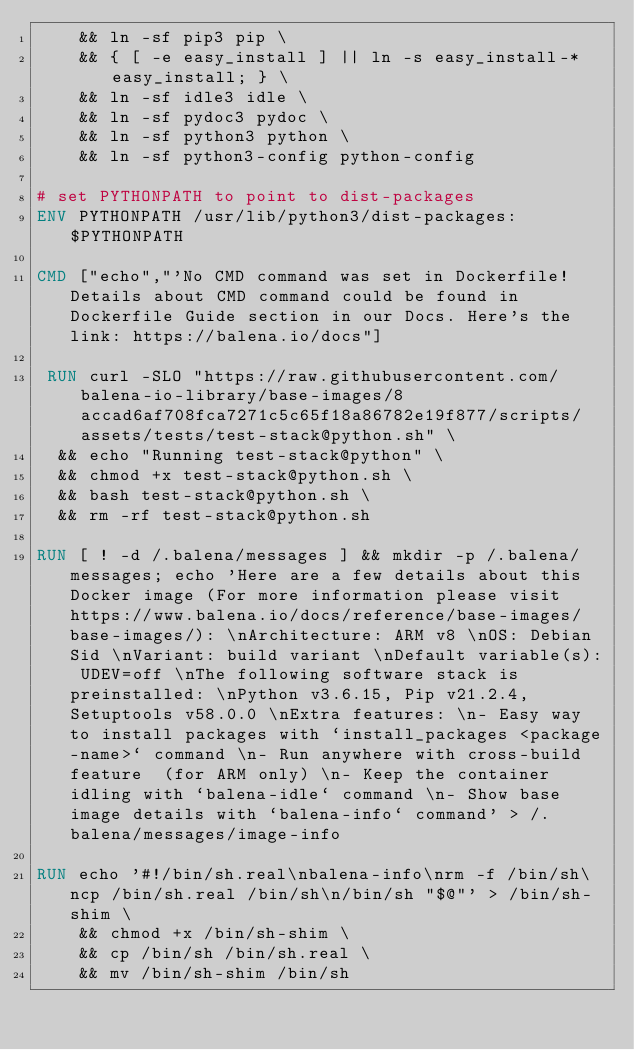Convert code to text. <code><loc_0><loc_0><loc_500><loc_500><_Dockerfile_>	&& ln -sf pip3 pip \
	&& { [ -e easy_install ] || ln -s easy_install-* easy_install; } \
	&& ln -sf idle3 idle \
	&& ln -sf pydoc3 pydoc \
	&& ln -sf python3 python \
	&& ln -sf python3-config python-config

# set PYTHONPATH to point to dist-packages
ENV PYTHONPATH /usr/lib/python3/dist-packages:$PYTHONPATH

CMD ["echo","'No CMD command was set in Dockerfile! Details about CMD command could be found in Dockerfile Guide section in our Docs. Here's the link: https://balena.io/docs"]

 RUN curl -SLO "https://raw.githubusercontent.com/balena-io-library/base-images/8accad6af708fca7271c5c65f18a86782e19f877/scripts/assets/tests/test-stack@python.sh" \
  && echo "Running test-stack@python" \
  && chmod +x test-stack@python.sh \
  && bash test-stack@python.sh \
  && rm -rf test-stack@python.sh 

RUN [ ! -d /.balena/messages ] && mkdir -p /.balena/messages; echo 'Here are a few details about this Docker image (For more information please visit https://www.balena.io/docs/reference/base-images/base-images/): \nArchitecture: ARM v8 \nOS: Debian Sid \nVariant: build variant \nDefault variable(s): UDEV=off \nThe following software stack is preinstalled: \nPython v3.6.15, Pip v21.2.4, Setuptools v58.0.0 \nExtra features: \n- Easy way to install packages with `install_packages <package-name>` command \n- Run anywhere with cross-build feature  (for ARM only) \n- Keep the container idling with `balena-idle` command \n- Show base image details with `balena-info` command' > /.balena/messages/image-info

RUN echo '#!/bin/sh.real\nbalena-info\nrm -f /bin/sh\ncp /bin/sh.real /bin/sh\n/bin/sh "$@"' > /bin/sh-shim \
	&& chmod +x /bin/sh-shim \
	&& cp /bin/sh /bin/sh.real \
	&& mv /bin/sh-shim /bin/sh</code> 